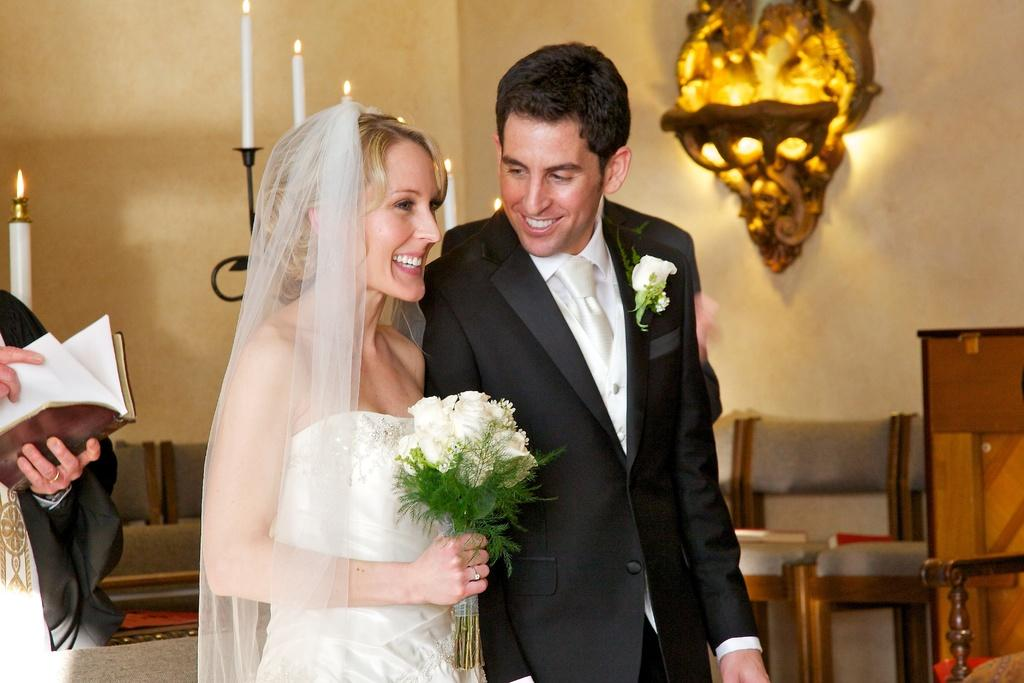Who are the two people in the room? There is a bride and groom in the room. What are the bride and groom doing in the image? The bride and groom are standing and smiling. What is the bride holding in the image? The bride is holding a bunch of white flowers. What type of furniture can be seen in the room? There are chairs in the room. Is there any decorative item in the room? Yes, there is a stand with a candle on it in the room. What type of feather is used to comb the bride's hair in the image? There is no feather or combing activity visible in the image. The bride is holding a bunch of white flowers, and there is no mention of her hair or any grooming tools. 